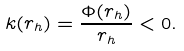<formula> <loc_0><loc_0><loc_500><loc_500>k ( r _ { h } ) = \frac { \Phi ( r _ { h } ) } { r _ { h } } < 0 .</formula> 